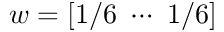Convert formula to latex. <formula><loc_0><loc_0><loc_500><loc_500>w = [ 1 / 6 \cdots 1 / 6 ]</formula> 